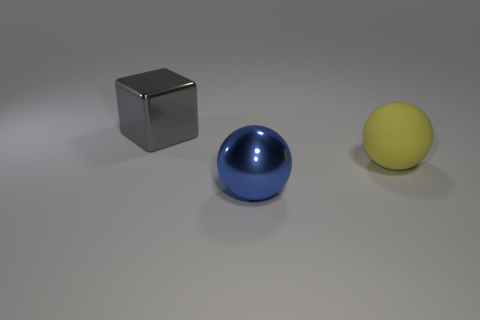Is there any other thing that has the same material as the yellow thing?
Your response must be concise. No. How many things are either large yellow matte objects or large balls that are to the left of the large yellow sphere?
Make the answer very short. 2. What number of objects are either things behind the big yellow rubber object or gray shiny things behind the large blue thing?
Your answer should be very brief. 1. Are there any yellow objects right of the large gray shiny cube?
Your answer should be very brief. Yes. What color is the big metallic thing that is right of the big shiny object on the left side of the large shiny thing that is in front of the large gray metallic block?
Provide a short and direct response. Blue. Do the rubber thing and the large blue thing have the same shape?
Your answer should be compact. Yes. There is a object that is the same material as the gray cube; what is its color?
Make the answer very short. Blue. What number of objects are either yellow objects that are behind the blue shiny thing or red balls?
Ensure brevity in your answer.  1. There is a metallic object that is behind the yellow matte object; what size is it?
Ensure brevity in your answer.  Large. What color is the shiny thing behind the metal thing in front of the gray thing?
Your answer should be compact. Gray. 